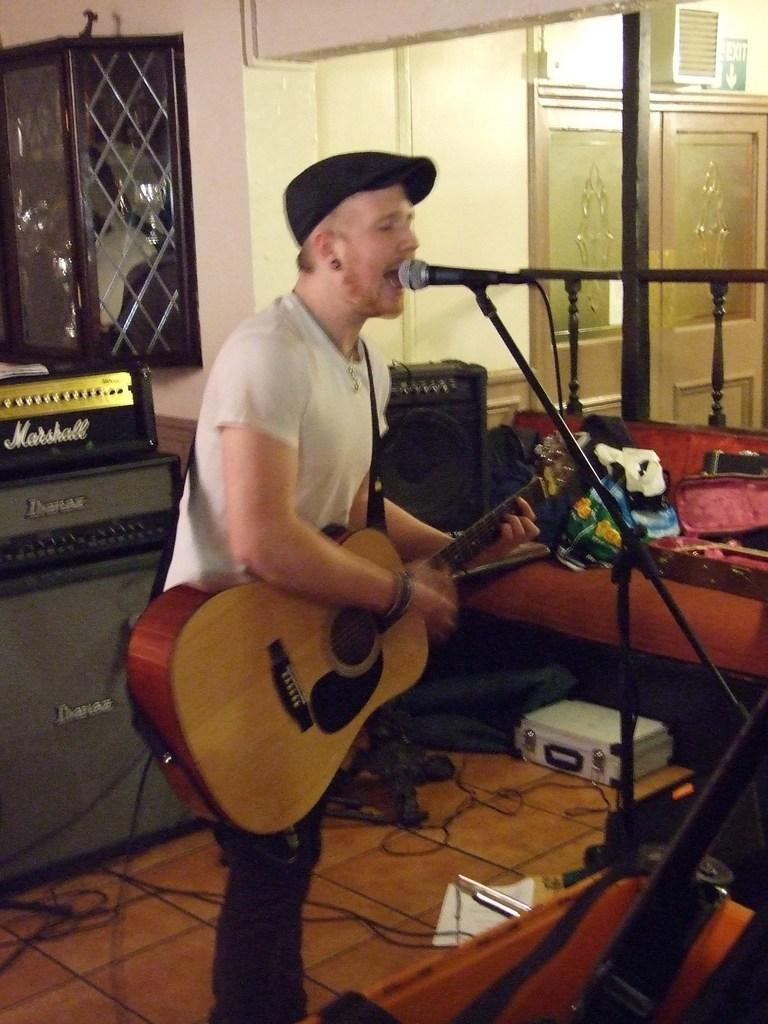What is the person in the image doing? The person in the image is playing a guitar and singing a song. What object is in front of the person? There is a microphone in front of the person. What other musical instruments are present in the image? There are other musical instruments present in the image. What type of cheese is being grated on the orange in the image? There is no orange or cheese present in the image; the scene features a person playing a guitar and singing with a microphone and other musical instruments. 